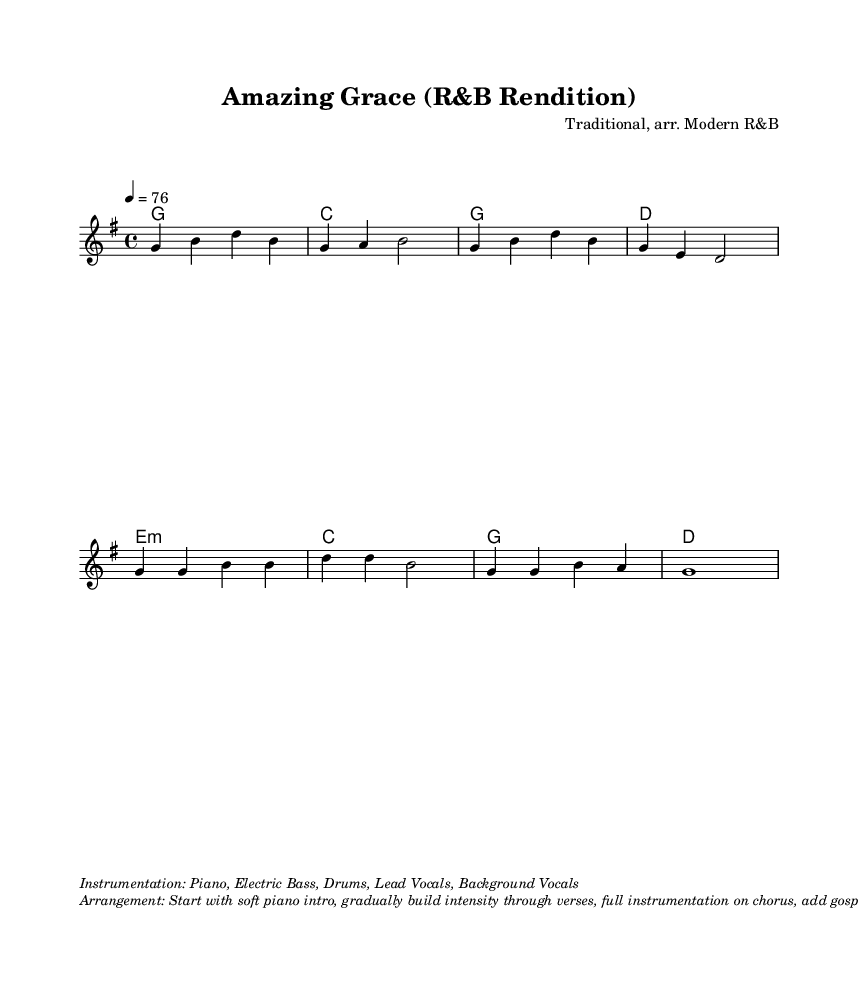What is the key signature of this music? The key signature indicates G major, which has one sharp (F#). You can see the sharp symbol placed on the F line in the staff at the beginning of the piece.
Answer: G major What is the time signature of this music? The time signature shown in the sheet music is 4/4. This information appears right after the clef and key signature, indicating there are four beats per measure and the quarter note gets one beat.
Answer: 4/4 What is the tempo marking for this piece? The tempo marking is indicated as "4 = 76," meaning there are 76 beats per minute and each quarter note gets one beat. This information is found in the header section of the music.
Answer: 76 How many measures are in the melody? Counting the distinct measures in the melody section, there are a total of eight measures presented in the staff. Each group of notes separated by vertical lines represents a measure.
Answer: 8 What type of instrumentation is used for this arrangement? The sheet music lists the instrumentation as: "Piano, Electric Bass, Drums, Lead Vocals, Background Vocals." This section appears at the bottom of the music, under the instrumental details.
Answer: Piano, Electric Bass, Drums, Lead Vocals, Background Vocals What is the primary function of the chorus in this piece? The chorus serves as the uplifting centerpiece of the song, emphasizing key lyrical themes. It is typically structured with repeated phrases and is marked by a shift in intensity, often meant for audience participation or vocal expression. The distinct lyrics can be identified in the chorus section of the sheet music.
Answer: Uplifting centerpiece How is the arrangement structured in terms of dynamic buildup? The arrangement starts soft with a piano intro, gradually builds intensity throughout the verses, reaches full instrumentation in the chorus, incorporates gospel-style elements, and concludes with powerful vocal ad-libs. This description is found in the arrangement details at the bottom of the sheet music.
Answer: Gradual buildup to powerful ad-libs 